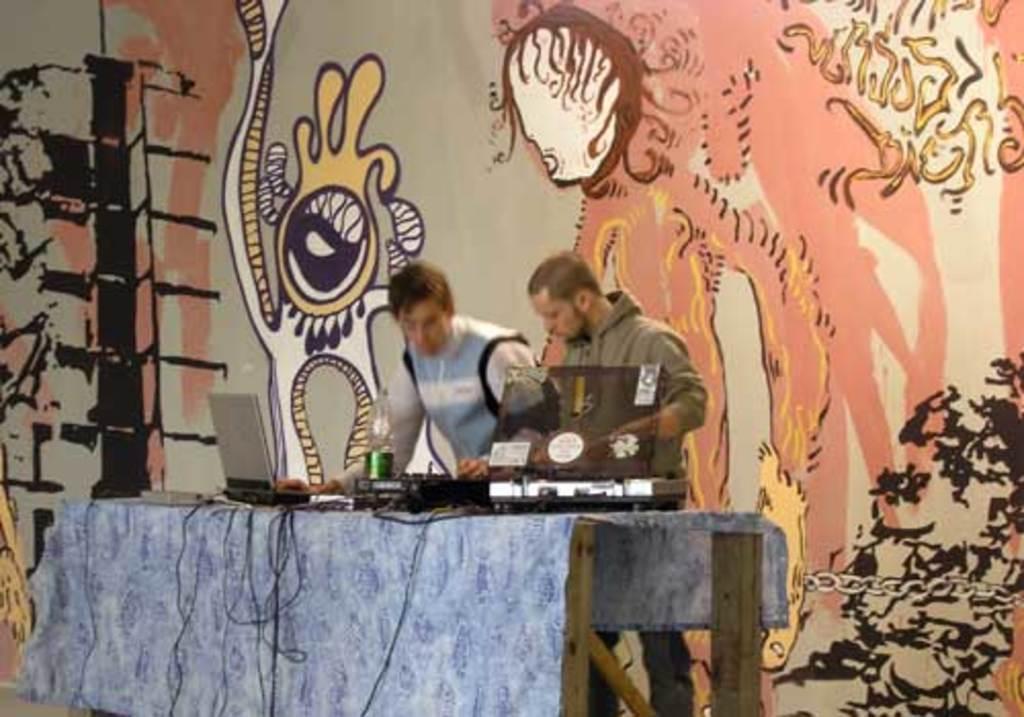Please provide a concise description of this image. In this image, we can see two persons wearing clothes and standing in front of the table. This table contains laptops and bottle. In the background of the image, there is a wall contains an art. 